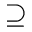<formula> <loc_0><loc_0><loc_500><loc_500>\supseteq</formula> 